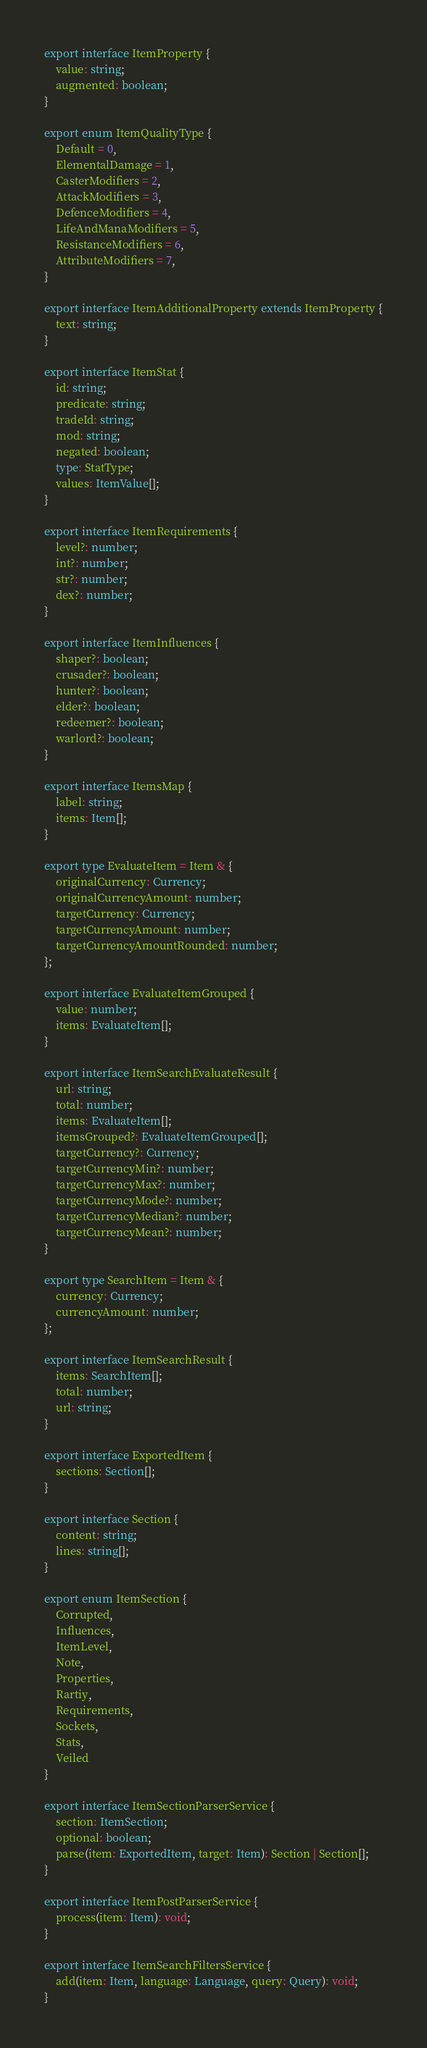Convert code to text. <code><loc_0><loc_0><loc_500><loc_500><_TypeScript_>
export interface ItemProperty {
    value: string;
    augmented: boolean;
}

export enum ItemQualityType {
    Default = 0,
    ElementalDamage = 1,
    CasterModifiers = 2,
    AttackModifiers = 3,
    DefenceModifiers = 4,
    LifeAndManaModifiers = 5,
    ResistanceModifiers = 6,
    AttributeModifiers = 7,
}

export interface ItemAdditionalProperty extends ItemProperty {
    text: string;
}

export interface ItemStat {
    id: string;
    predicate: string;
    tradeId: string;
    mod: string;
    negated: boolean;
    type: StatType;
    values: ItemValue[];
}

export interface ItemRequirements {
    level?: number;
    int?: number;
    str?: number;
    dex?: number;
}

export interface ItemInfluences {
    shaper?: boolean;
    crusader?: boolean;
    hunter?: boolean;
    elder?: boolean;
    redeemer?: boolean;
    warlord?: boolean;
}

export interface ItemsMap {
    label: string;
    items: Item[];
}

export type EvaluateItem = Item & {
    originalCurrency: Currency;
    originalCurrencyAmount: number;
    targetCurrency: Currency;
    targetCurrencyAmount: number;
    targetCurrencyAmountRounded: number;
};

export interface EvaluateItemGrouped {
    value: number;
    items: EvaluateItem[];
}

export interface ItemSearchEvaluateResult {
    url: string;
    total: number;
    items: EvaluateItem[];
    itemsGrouped?: EvaluateItemGrouped[];
    targetCurrency?: Currency;
    targetCurrencyMin?: number;
    targetCurrencyMax?: number;
    targetCurrencyMode?: number;
    targetCurrencyMedian?: number;
    targetCurrencyMean?: number;
}

export type SearchItem = Item & {
    currency: Currency;
    currencyAmount: number;
};

export interface ItemSearchResult {
    items: SearchItem[];
    total: number;
    url: string;
}

export interface ExportedItem {
    sections: Section[];
}

export interface Section {
    content: string;
    lines: string[];
}

export enum ItemSection {
    Corrupted,
    Influences,
    ItemLevel,
    Note,
    Properties,
    Rartiy,
    Requirements,
    Sockets,
    Stats,
    Veiled
}

export interface ItemSectionParserService {
    section: ItemSection;
    optional: boolean;
    parse(item: ExportedItem, target: Item): Section | Section[];
}

export interface ItemPostParserService {
    process(item: Item): void;
}

export interface ItemSearchFiltersService {
    add(item: Item, language: Language, query: Query): void;
}
</code> 